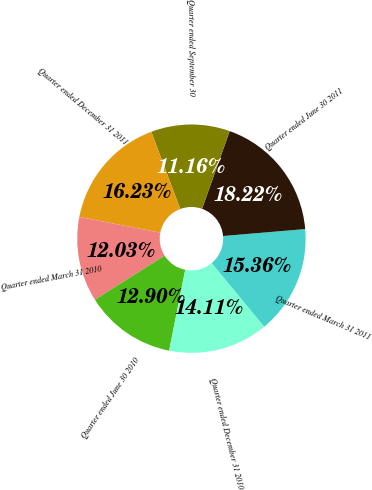<chart> <loc_0><loc_0><loc_500><loc_500><pie_chart><fcel>Quarter ended March 31 2011<fcel>Quarter ended June 30 2011<fcel>Quarter ended September 30<fcel>Quarter ended December 31 2011<fcel>Quarter ended March 31 2010<fcel>Quarter ended June 30 2010<fcel>Quarter ended December 31 2010<nl><fcel>15.36%<fcel>18.22%<fcel>11.16%<fcel>16.23%<fcel>12.03%<fcel>12.9%<fcel>14.11%<nl></chart> 